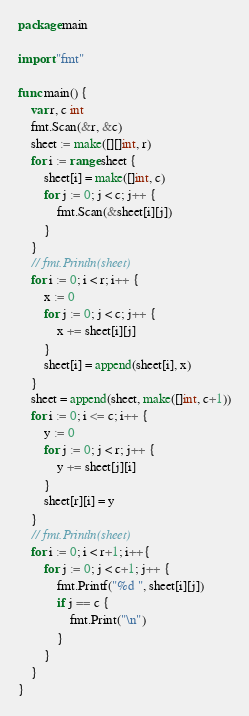Convert code to text. <code><loc_0><loc_0><loc_500><loc_500><_Go_>package main

import "fmt"

func main() {
	var r, c int
	fmt.Scan(&r, &c)
	sheet := make([][]int, r)
	for i := range sheet {
		sheet[i] = make([]int, c)
		for j := 0; j < c; j++ {
			fmt.Scan(&sheet[i][j])
		}
	}
	// fmt.Println(sheet)
	for i := 0; i < r; i++ {
		x := 0
		for j := 0; j < c; j++ {
			x += sheet[i][j]
		}
		sheet[i] = append(sheet[i], x)
	}
	sheet = append(sheet, make([]int, c+1))
	for i := 0; i <= c; i++ {
		y := 0
		for j := 0; j < r; j++ {
			y += sheet[j][i]
		}
		sheet[r][i] = y
	}
	// fmt.Println(sheet)
	for i := 0; i < r+1; i++{
		for j := 0; j < c+1; j++ {
			fmt.Printf("%d ", sheet[i][j])
			if j == c {
				fmt.Print("\n")
			}
		}
	}
}
</code> 